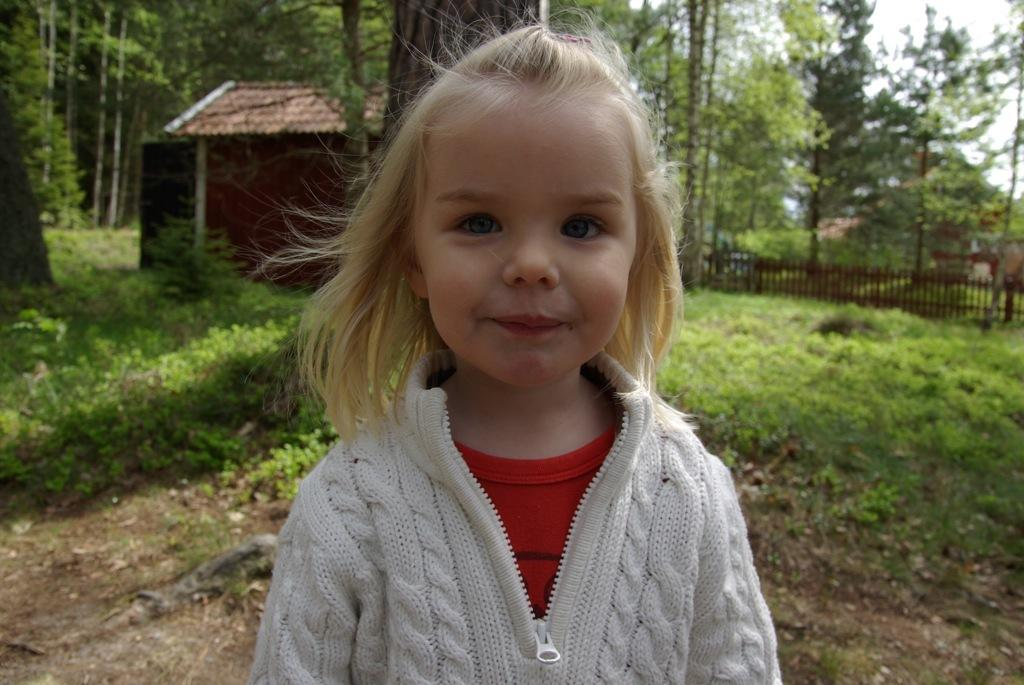Who is the main subject in the foreground of the image? There is a girl in the foreground of the image. What is the girl wearing? The girl is wearing a dress. What can be seen in the background of the image? There is a fence, buildings, a group of trees, grass, and the sky visible in the background of the image. What type of shoe is the girl wearing in the image? The facts provided do not mention any shoes, so we cannot determine the type of shoe the girl is wearing. --- Facts: 1. There is a car in the image. 2. The car is red. 3. The car has four wheels. 4. There are people in the car. 5. The car is parked on the street. 6. There are trees on the side of the street. Absurd Topics: parrot, sand, volcano Conversation: What is the main subject in the image? The main subject in the image is a car. What color is the car? The car is red. How many wheels does the car have? The car has four wheels. Who is inside the car? There are people in the car. Where is the car located? The car is parked on the street. What can be seen on the side of the street? There are trees on the side of the street. Reasoning: Let's think step by step in order to produce the conversation. We start by identifying the main subject in the image, which is the car. Then, we describe the car's color and the number of wheels it has. Next, we mention the people inside the car and its location, which is parked on the street. Finally, we describe the surrounding environment, which includes trees on the side of the street. Each question is designed to elicit a specific detail about the image that is known from the facts provided. Absurd Question/Answer: Can you see a volcano erupting in the background of the image? No, there is no volcano or any indication of an eruption in the image. 